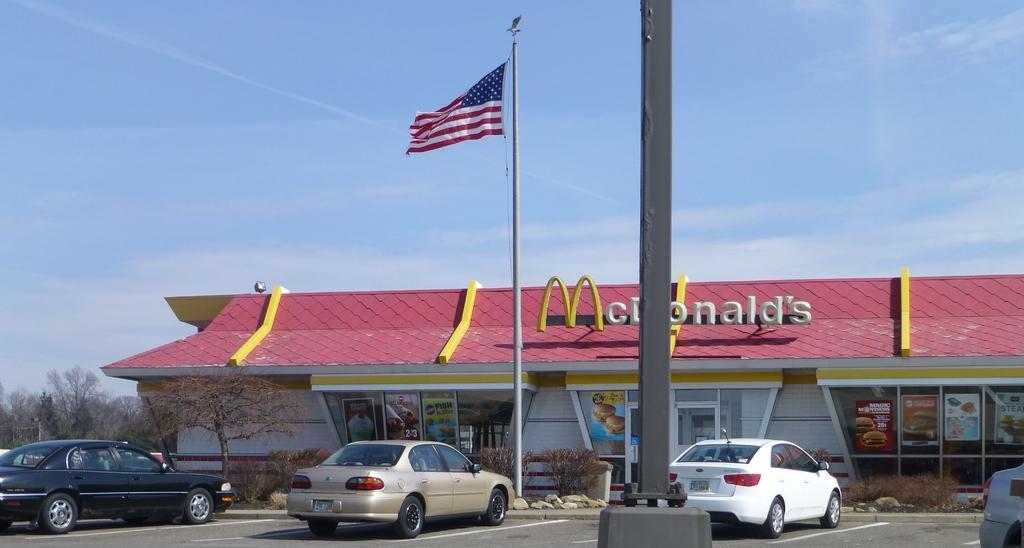Please provide a concise description of this image. This image consists of a restaurant. In the front, we can see a pole and a flag. And there are four cars parked on the road. On the left, there are trees. At the top, there is sky. 